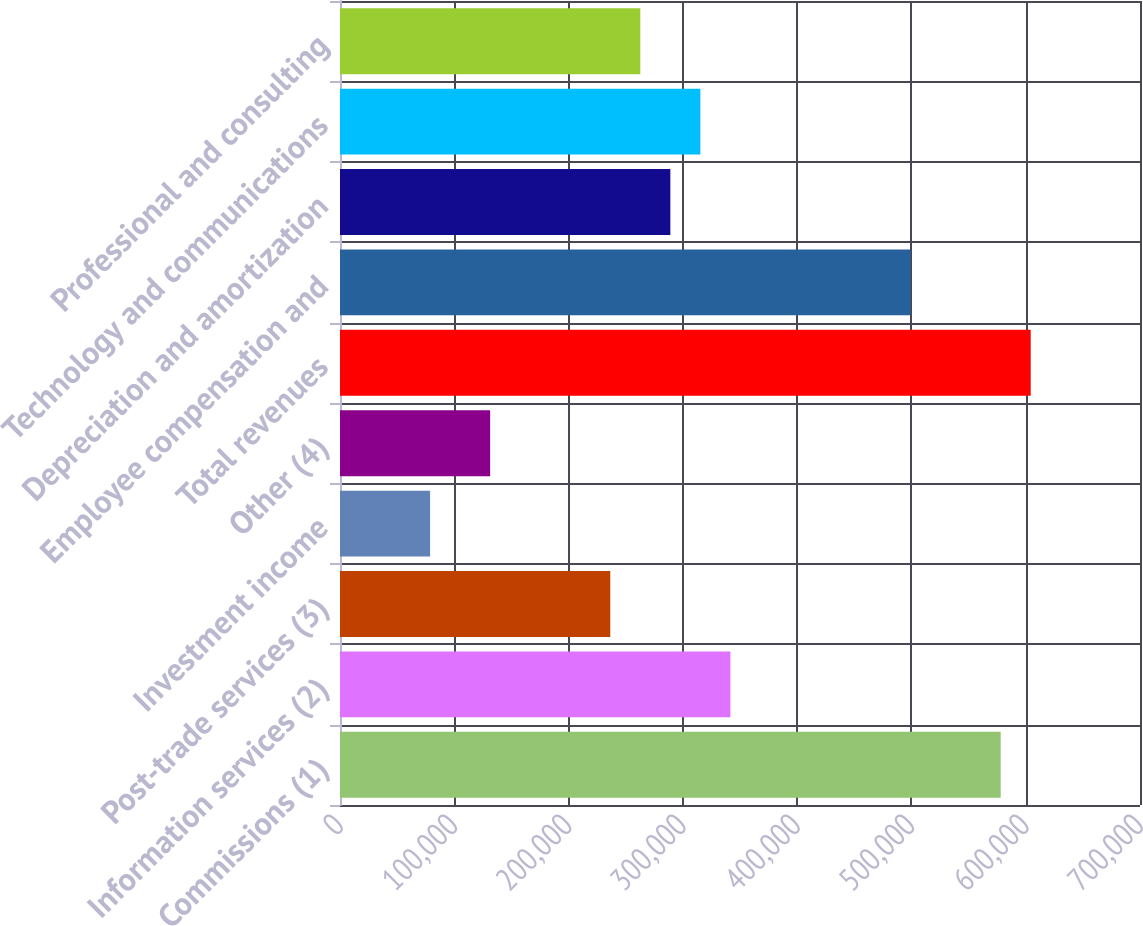<chart> <loc_0><loc_0><loc_500><loc_500><bar_chart><fcel>Commissions (1)<fcel>Information services (2)<fcel>Post-trade services (3)<fcel>Investment income<fcel>Other (4)<fcel>Total revenues<fcel>Employee compensation and<fcel>Depreciation and amortization<fcel>Technology and communications<fcel>Professional and consulting<nl><fcel>578102<fcel>341606<fcel>236497<fcel>78832.7<fcel>131387<fcel>604379<fcel>499270<fcel>289051<fcel>315329<fcel>262774<nl></chart> 